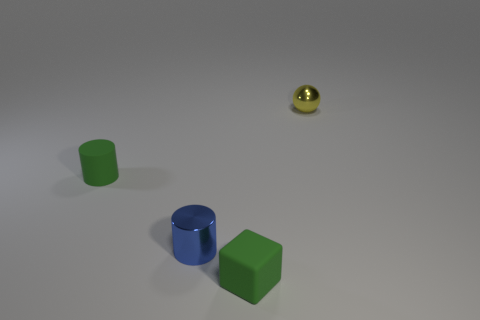There is a metal thing that is in front of the yellow thing; are there any blue metallic objects that are right of it?
Keep it short and to the point. No. Does the matte object that is behind the matte cube have the same color as the shiny thing that is in front of the yellow shiny object?
Your response must be concise. No. The ball is what color?
Provide a succinct answer. Yellow. Is there anything else of the same color as the metal sphere?
Make the answer very short. No. There is a small object that is left of the green cube and right of the green cylinder; what is its color?
Give a very brief answer. Blue. There is a green rubber thing right of the green rubber cylinder; is it the same size as the tiny yellow metallic sphere?
Your response must be concise. Yes. Is the number of tiny metal cylinders that are behind the yellow sphere greater than the number of tiny matte things?
Give a very brief answer. No. Is the small yellow object the same shape as the blue metallic thing?
Provide a short and direct response. No. What is the size of the yellow metal thing?
Offer a very short reply. Small. Is the number of small blue shiny cylinders that are to the right of the cube greater than the number of yellow metal objects in front of the tiny matte cylinder?
Offer a very short reply. No. 